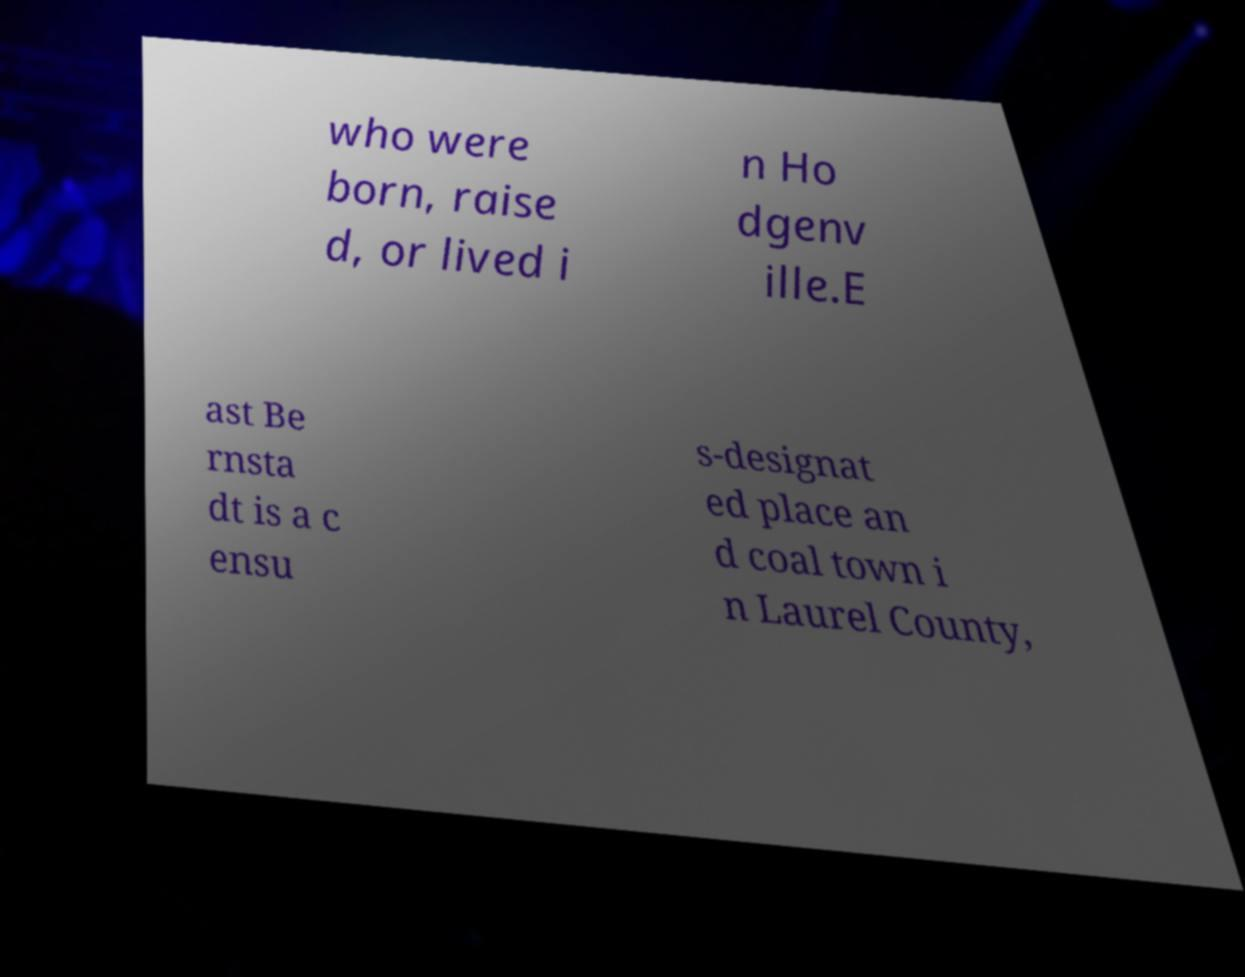Can you read and provide the text displayed in the image?This photo seems to have some interesting text. Can you extract and type it out for me? who were born, raise d, or lived i n Ho dgenv ille.E ast Be rnsta dt is a c ensu s-designat ed place an d coal town i n Laurel County, 